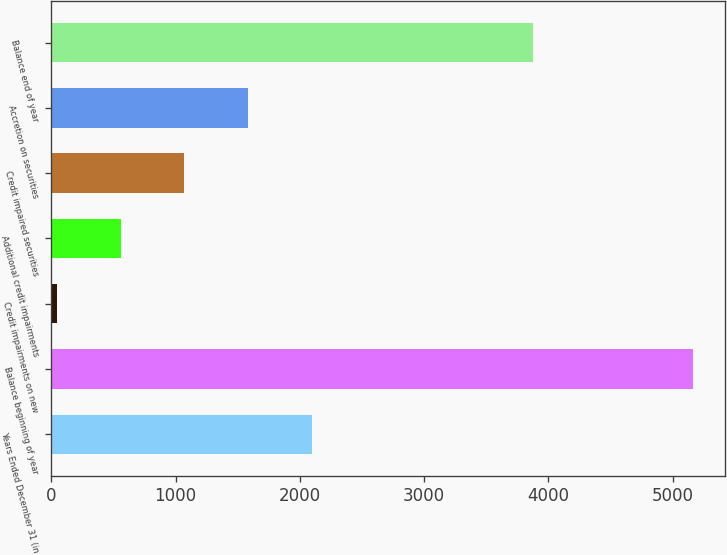<chart> <loc_0><loc_0><loc_500><loc_500><bar_chart><fcel>Years Ended December 31 (in<fcel>Balance beginning of year<fcel>Credit impairments on new<fcel>Additional credit impairments<fcel>Credit impaired securities<fcel>Accretion on securities<fcel>Balance end of year<nl><fcel>2093.8<fcel>5164<fcel>47<fcel>558.7<fcel>1070.4<fcel>1582.1<fcel>3872<nl></chart> 